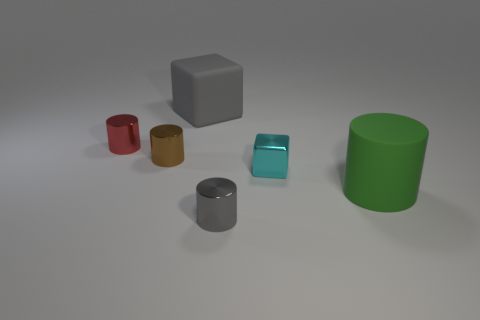What number of purple objects are either shiny things or cylinders?
Your response must be concise. 0. How many big blocks are left of the large green object?
Offer a very short reply. 1. Is the number of purple balls greater than the number of large matte cylinders?
Your answer should be compact. No. What shape is the big object on the left side of the large matte object that is on the right side of the big gray matte thing?
Your answer should be very brief. Cube. Is the metallic block the same color as the big cube?
Your answer should be compact. No. Is the number of gray cylinders that are left of the gray rubber object greater than the number of red metallic spheres?
Your answer should be very brief. No. What number of gray cubes are left of the gray object that is right of the matte block?
Give a very brief answer. 1. Is the small cylinder that is on the right side of the rubber cube made of the same material as the gray cube that is behind the large cylinder?
Provide a succinct answer. No. There is a tiny thing that is the same color as the rubber cube; what material is it?
Your answer should be compact. Metal. How many blue matte objects are the same shape as the small gray thing?
Give a very brief answer. 0. 